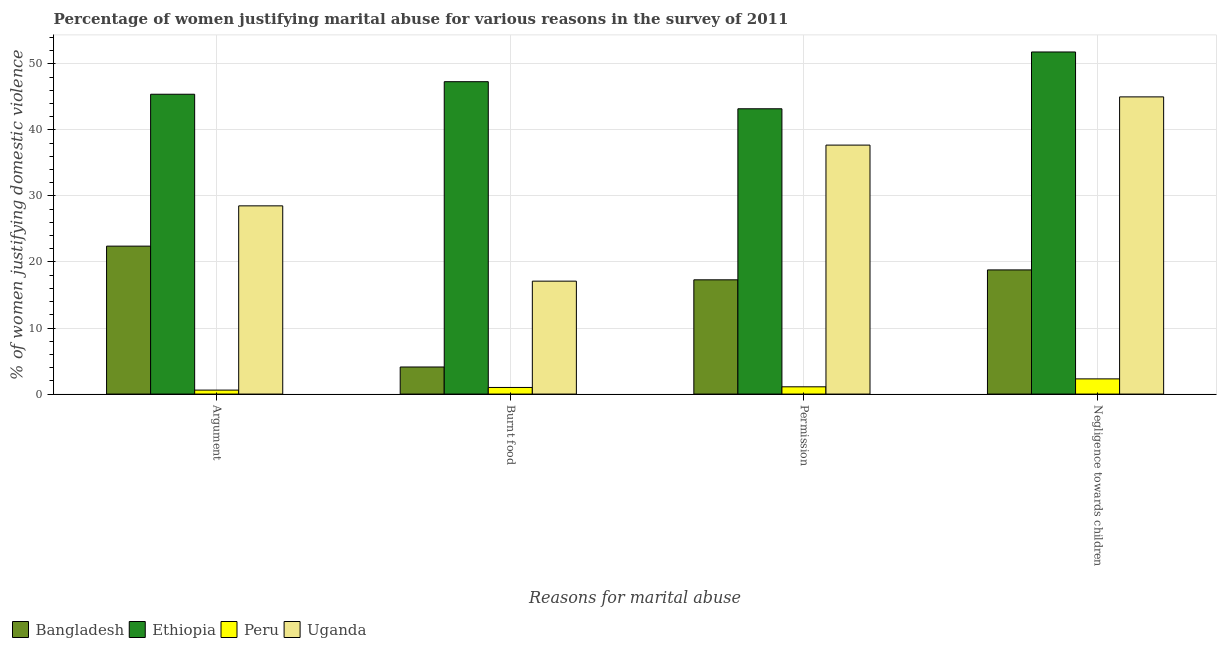How many different coloured bars are there?
Keep it short and to the point. 4. How many groups of bars are there?
Keep it short and to the point. 4. Are the number of bars on each tick of the X-axis equal?
Offer a very short reply. Yes. How many bars are there on the 3rd tick from the right?
Your answer should be very brief. 4. What is the label of the 4th group of bars from the left?
Your answer should be very brief. Negligence towards children. What is the percentage of women justifying abuse for showing negligence towards children in Uganda?
Offer a very short reply. 45. Across all countries, what is the maximum percentage of women justifying abuse for going without permission?
Provide a succinct answer. 43.2. In which country was the percentage of women justifying abuse for going without permission maximum?
Your response must be concise. Ethiopia. In which country was the percentage of women justifying abuse for burning food minimum?
Provide a succinct answer. Peru. What is the total percentage of women justifying abuse for going without permission in the graph?
Ensure brevity in your answer.  99.3. What is the difference between the percentage of women justifying abuse for showing negligence towards children in Peru and that in Uganda?
Give a very brief answer. -42.7. What is the difference between the percentage of women justifying abuse in the case of an argument in Ethiopia and the percentage of women justifying abuse for going without permission in Uganda?
Make the answer very short. 7.7. What is the average percentage of women justifying abuse for burning food per country?
Offer a very short reply. 17.38. What is the difference between the percentage of women justifying abuse in the case of an argument and percentage of women justifying abuse for showing negligence towards children in Uganda?
Offer a very short reply. -16.5. What is the ratio of the percentage of women justifying abuse in the case of an argument in Peru to that in Ethiopia?
Ensure brevity in your answer.  0.01. Is the percentage of women justifying abuse for burning food in Peru less than that in Ethiopia?
Keep it short and to the point. Yes. What is the difference between the highest and the lowest percentage of women justifying abuse for showing negligence towards children?
Offer a terse response. 49.5. In how many countries, is the percentage of women justifying abuse in the case of an argument greater than the average percentage of women justifying abuse in the case of an argument taken over all countries?
Keep it short and to the point. 2. What does the 4th bar from the left in Burnt food represents?
Ensure brevity in your answer.  Uganda. What does the 2nd bar from the right in Burnt food represents?
Offer a very short reply. Peru. Is it the case that in every country, the sum of the percentage of women justifying abuse in the case of an argument and percentage of women justifying abuse for burning food is greater than the percentage of women justifying abuse for going without permission?
Your response must be concise. Yes. How many bars are there?
Make the answer very short. 16. How many countries are there in the graph?
Your answer should be compact. 4. Does the graph contain any zero values?
Give a very brief answer. No. How are the legend labels stacked?
Keep it short and to the point. Horizontal. What is the title of the graph?
Make the answer very short. Percentage of women justifying marital abuse for various reasons in the survey of 2011. Does "Kuwait" appear as one of the legend labels in the graph?
Your answer should be very brief. No. What is the label or title of the X-axis?
Provide a short and direct response. Reasons for marital abuse. What is the label or title of the Y-axis?
Your response must be concise. % of women justifying domestic violence. What is the % of women justifying domestic violence in Bangladesh in Argument?
Your answer should be very brief. 22.4. What is the % of women justifying domestic violence of Ethiopia in Argument?
Your answer should be very brief. 45.4. What is the % of women justifying domestic violence of Ethiopia in Burnt food?
Make the answer very short. 47.3. What is the % of women justifying domestic violence of Peru in Burnt food?
Your answer should be compact. 1. What is the % of women justifying domestic violence of Uganda in Burnt food?
Ensure brevity in your answer.  17.1. What is the % of women justifying domestic violence of Bangladesh in Permission?
Make the answer very short. 17.3. What is the % of women justifying domestic violence of Ethiopia in Permission?
Your answer should be very brief. 43.2. What is the % of women justifying domestic violence of Peru in Permission?
Give a very brief answer. 1.1. What is the % of women justifying domestic violence of Uganda in Permission?
Give a very brief answer. 37.7. What is the % of women justifying domestic violence of Ethiopia in Negligence towards children?
Your answer should be compact. 51.8. What is the % of women justifying domestic violence of Peru in Negligence towards children?
Provide a succinct answer. 2.3. Across all Reasons for marital abuse, what is the maximum % of women justifying domestic violence in Bangladesh?
Keep it short and to the point. 22.4. Across all Reasons for marital abuse, what is the maximum % of women justifying domestic violence of Ethiopia?
Make the answer very short. 51.8. Across all Reasons for marital abuse, what is the maximum % of women justifying domestic violence in Peru?
Your answer should be very brief. 2.3. Across all Reasons for marital abuse, what is the maximum % of women justifying domestic violence of Uganda?
Offer a very short reply. 45. Across all Reasons for marital abuse, what is the minimum % of women justifying domestic violence in Bangladesh?
Your answer should be very brief. 4.1. Across all Reasons for marital abuse, what is the minimum % of women justifying domestic violence of Ethiopia?
Ensure brevity in your answer.  43.2. Across all Reasons for marital abuse, what is the minimum % of women justifying domestic violence in Uganda?
Ensure brevity in your answer.  17.1. What is the total % of women justifying domestic violence of Bangladesh in the graph?
Keep it short and to the point. 62.6. What is the total % of women justifying domestic violence of Ethiopia in the graph?
Offer a terse response. 187.7. What is the total % of women justifying domestic violence of Peru in the graph?
Your response must be concise. 5. What is the total % of women justifying domestic violence in Uganda in the graph?
Your answer should be compact. 128.3. What is the difference between the % of women justifying domestic violence of Bangladesh in Argument and that in Burnt food?
Make the answer very short. 18.3. What is the difference between the % of women justifying domestic violence of Ethiopia in Argument and that in Burnt food?
Your answer should be very brief. -1.9. What is the difference between the % of women justifying domestic violence of Peru in Argument and that in Permission?
Provide a short and direct response. -0.5. What is the difference between the % of women justifying domestic violence of Uganda in Argument and that in Permission?
Keep it short and to the point. -9.2. What is the difference between the % of women justifying domestic violence of Bangladesh in Argument and that in Negligence towards children?
Your response must be concise. 3.6. What is the difference between the % of women justifying domestic violence in Uganda in Argument and that in Negligence towards children?
Your answer should be compact. -16.5. What is the difference between the % of women justifying domestic violence of Bangladesh in Burnt food and that in Permission?
Provide a short and direct response. -13.2. What is the difference between the % of women justifying domestic violence of Ethiopia in Burnt food and that in Permission?
Offer a terse response. 4.1. What is the difference between the % of women justifying domestic violence in Uganda in Burnt food and that in Permission?
Your answer should be compact. -20.6. What is the difference between the % of women justifying domestic violence in Bangladesh in Burnt food and that in Negligence towards children?
Provide a short and direct response. -14.7. What is the difference between the % of women justifying domestic violence of Ethiopia in Burnt food and that in Negligence towards children?
Ensure brevity in your answer.  -4.5. What is the difference between the % of women justifying domestic violence in Peru in Burnt food and that in Negligence towards children?
Ensure brevity in your answer.  -1.3. What is the difference between the % of women justifying domestic violence of Uganda in Burnt food and that in Negligence towards children?
Keep it short and to the point. -27.9. What is the difference between the % of women justifying domestic violence in Bangladesh in Permission and that in Negligence towards children?
Make the answer very short. -1.5. What is the difference between the % of women justifying domestic violence of Ethiopia in Permission and that in Negligence towards children?
Your response must be concise. -8.6. What is the difference between the % of women justifying domestic violence of Peru in Permission and that in Negligence towards children?
Give a very brief answer. -1.2. What is the difference between the % of women justifying domestic violence of Uganda in Permission and that in Negligence towards children?
Your answer should be compact. -7.3. What is the difference between the % of women justifying domestic violence of Bangladesh in Argument and the % of women justifying domestic violence of Ethiopia in Burnt food?
Your answer should be very brief. -24.9. What is the difference between the % of women justifying domestic violence of Bangladesh in Argument and the % of women justifying domestic violence of Peru in Burnt food?
Your answer should be compact. 21.4. What is the difference between the % of women justifying domestic violence in Bangladesh in Argument and the % of women justifying domestic violence in Uganda in Burnt food?
Your answer should be compact. 5.3. What is the difference between the % of women justifying domestic violence of Ethiopia in Argument and the % of women justifying domestic violence of Peru in Burnt food?
Provide a short and direct response. 44.4. What is the difference between the % of women justifying domestic violence in Ethiopia in Argument and the % of women justifying domestic violence in Uganda in Burnt food?
Make the answer very short. 28.3. What is the difference between the % of women justifying domestic violence of Peru in Argument and the % of women justifying domestic violence of Uganda in Burnt food?
Provide a short and direct response. -16.5. What is the difference between the % of women justifying domestic violence in Bangladesh in Argument and the % of women justifying domestic violence in Ethiopia in Permission?
Keep it short and to the point. -20.8. What is the difference between the % of women justifying domestic violence in Bangladesh in Argument and the % of women justifying domestic violence in Peru in Permission?
Your answer should be compact. 21.3. What is the difference between the % of women justifying domestic violence in Bangladesh in Argument and the % of women justifying domestic violence in Uganda in Permission?
Offer a very short reply. -15.3. What is the difference between the % of women justifying domestic violence of Ethiopia in Argument and the % of women justifying domestic violence of Peru in Permission?
Your response must be concise. 44.3. What is the difference between the % of women justifying domestic violence of Peru in Argument and the % of women justifying domestic violence of Uganda in Permission?
Your response must be concise. -37.1. What is the difference between the % of women justifying domestic violence of Bangladesh in Argument and the % of women justifying domestic violence of Ethiopia in Negligence towards children?
Offer a very short reply. -29.4. What is the difference between the % of women justifying domestic violence in Bangladesh in Argument and the % of women justifying domestic violence in Peru in Negligence towards children?
Ensure brevity in your answer.  20.1. What is the difference between the % of women justifying domestic violence of Bangladesh in Argument and the % of women justifying domestic violence of Uganda in Negligence towards children?
Your answer should be very brief. -22.6. What is the difference between the % of women justifying domestic violence of Ethiopia in Argument and the % of women justifying domestic violence of Peru in Negligence towards children?
Offer a very short reply. 43.1. What is the difference between the % of women justifying domestic violence in Peru in Argument and the % of women justifying domestic violence in Uganda in Negligence towards children?
Provide a short and direct response. -44.4. What is the difference between the % of women justifying domestic violence of Bangladesh in Burnt food and the % of women justifying domestic violence of Ethiopia in Permission?
Provide a succinct answer. -39.1. What is the difference between the % of women justifying domestic violence of Bangladesh in Burnt food and the % of women justifying domestic violence of Peru in Permission?
Make the answer very short. 3. What is the difference between the % of women justifying domestic violence of Bangladesh in Burnt food and the % of women justifying domestic violence of Uganda in Permission?
Keep it short and to the point. -33.6. What is the difference between the % of women justifying domestic violence in Ethiopia in Burnt food and the % of women justifying domestic violence in Peru in Permission?
Provide a succinct answer. 46.2. What is the difference between the % of women justifying domestic violence in Ethiopia in Burnt food and the % of women justifying domestic violence in Uganda in Permission?
Ensure brevity in your answer.  9.6. What is the difference between the % of women justifying domestic violence in Peru in Burnt food and the % of women justifying domestic violence in Uganda in Permission?
Your answer should be very brief. -36.7. What is the difference between the % of women justifying domestic violence of Bangladesh in Burnt food and the % of women justifying domestic violence of Ethiopia in Negligence towards children?
Give a very brief answer. -47.7. What is the difference between the % of women justifying domestic violence of Bangladesh in Burnt food and the % of women justifying domestic violence of Uganda in Negligence towards children?
Your response must be concise. -40.9. What is the difference between the % of women justifying domestic violence of Ethiopia in Burnt food and the % of women justifying domestic violence of Peru in Negligence towards children?
Your answer should be very brief. 45. What is the difference between the % of women justifying domestic violence in Peru in Burnt food and the % of women justifying domestic violence in Uganda in Negligence towards children?
Give a very brief answer. -44. What is the difference between the % of women justifying domestic violence of Bangladesh in Permission and the % of women justifying domestic violence of Ethiopia in Negligence towards children?
Keep it short and to the point. -34.5. What is the difference between the % of women justifying domestic violence in Bangladesh in Permission and the % of women justifying domestic violence in Peru in Negligence towards children?
Give a very brief answer. 15. What is the difference between the % of women justifying domestic violence in Bangladesh in Permission and the % of women justifying domestic violence in Uganda in Negligence towards children?
Make the answer very short. -27.7. What is the difference between the % of women justifying domestic violence in Ethiopia in Permission and the % of women justifying domestic violence in Peru in Negligence towards children?
Your answer should be compact. 40.9. What is the difference between the % of women justifying domestic violence of Peru in Permission and the % of women justifying domestic violence of Uganda in Negligence towards children?
Your response must be concise. -43.9. What is the average % of women justifying domestic violence of Bangladesh per Reasons for marital abuse?
Offer a very short reply. 15.65. What is the average % of women justifying domestic violence in Ethiopia per Reasons for marital abuse?
Provide a short and direct response. 46.92. What is the average % of women justifying domestic violence in Peru per Reasons for marital abuse?
Provide a short and direct response. 1.25. What is the average % of women justifying domestic violence of Uganda per Reasons for marital abuse?
Offer a terse response. 32.08. What is the difference between the % of women justifying domestic violence of Bangladesh and % of women justifying domestic violence of Peru in Argument?
Keep it short and to the point. 21.8. What is the difference between the % of women justifying domestic violence in Bangladesh and % of women justifying domestic violence in Uganda in Argument?
Make the answer very short. -6.1. What is the difference between the % of women justifying domestic violence in Ethiopia and % of women justifying domestic violence in Peru in Argument?
Offer a very short reply. 44.8. What is the difference between the % of women justifying domestic violence of Peru and % of women justifying domestic violence of Uganda in Argument?
Your answer should be compact. -27.9. What is the difference between the % of women justifying domestic violence of Bangladesh and % of women justifying domestic violence of Ethiopia in Burnt food?
Provide a succinct answer. -43.2. What is the difference between the % of women justifying domestic violence of Bangladesh and % of women justifying domestic violence of Peru in Burnt food?
Ensure brevity in your answer.  3.1. What is the difference between the % of women justifying domestic violence of Ethiopia and % of women justifying domestic violence of Peru in Burnt food?
Keep it short and to the point. 46.3. What is the difference between the % of women justifying domestic violence in Ethiopia and % of women justifying domestic violence in Uganda in Burnt food?
Provide a short and direct response. 30.2. What is the difference between the % of women justifying domestic violence in Peru and % of women justifying domestic violence in Uganda in Burnt food?
Provide a succinct answer. -16.1. What is the difference between the % of women justifying domestic violence in Bangladesh and % of women justifying domestic violence in Ethiopia in Permission?
Make the answer very short. -25.9. What is the difference between the % of women justifying domestic violence in Bangladesh and % of women justifying domestic violence in Uganda in Permission?
Your response must be concise. -20.4. What is the difference between the % of women justifying domestic violence of Ethiopia and % of women justifying domestic violence of Peru in Permission?
Ensure brevity in your answer.  42.1. What is the difference between the % of women justifying domestic violence of Ethiopia and % of women justifying domestic violence of Uganda in Permission?
Provide a short and direct response. 5.5. What is the difference between the % of women justifying domestic violence of Peru and % of women justifying domestic violence of Uganda in Permission?
Ensure brevity in your answer.  -36.6. What is the difference between the % of women justifying domestic violence of Bangladesh and % of women justifying domestic violence of Ethiopia in Negligence towards children?
Provide a succinct answer. -33. What is the difference between the % of women justifying domestic violence of Bangladesh and % of women justifying domestic violence of Uganda in Negligence towards children?
Your answer should be very brief. -26.2. What is the difference between the % of women justifying domestic violence in Ethiopia and % of women justifying domestic violence in Peru in Negligence towards children?
Make the answer very short. 49.5. What is the difference between the % of women justifying domestic violence in Peru and % of women justifying domestic violence in Uganda in Negligence towards children?
Your response must be concise. -42.7. What is the ratio of the % of women justifying domestic violence in Bangladesh in Argument to that in Burnt food?
Your response must be concise. 5.46. What is the ratio of the % of women justifying domestic violence in Ethiopia in Argument to that in Burnt food?
Ensure brevity in your answer.  0.96. What is the ratio of the % of women justifying domestic violence in Bangladesh in Argument to that in Permission?
Provide a succinct answer. 1.29. What is the ratio of the % of women justifying domestic violence of Ethiopia in Argument to that in Permission?
Offer a terse response. 1.05. What is the ratio of the % of women justifying domestic violence in Peru in Argument to that in Permission?
Your answer should be very brief. 0.55. What is the ratio of the % of women justifying domestic violence of Uganda in Argument to that in Permission?
Make the answer very short. 0.76. What is the ratio of the % of women justifying domestic violence in Bangladesh in Argument to that in Negligence towards children?
Make the answer very short. 1.19. What is the ratio of the % of women justifying domestic violence of Ethiopia in Argument to that in Negligence towards children?
Give a very brief answer. 0.88. What is the ratio of the % of women justifying domestic violence in Peru in Argument to that in Negligence towards children?
Your response must be concise. 0.26. What is the ratio of the % of women justifying domestic violence of Uganda in Argument to that in Negligence towards children?
Your response must be concise. 0.63. What is the ratio of the % of women justifying domestic violence of Bangladesh in Burnt food to that in Permission?
Your response must be concise. 0.24. What is the ratio of the % of women justifying domestic violence of Ethiopia in Burnt food to that in Permission?
Your answer should be very brief. 1.09. What is the ratio of the % of women justifying domestic violence of Peru in Burnt food to that in Permission?
Offer a terse response. 0.91. What is the ratio of the % of women justifying domestic violence of Uganda in Burnt food to that in Permission?
Keep it short and to the point. 0.45. What is the ratio of the % of women justifying domestic violence of Bangladesh in Burnt food to that in Negligence towards children?
Provide a short and direct response. 0.22. What is the ratio of the % of women justifying domestic violence of Ethiopia in Burnt food to that in Negligence towards children?
Your response must be concise. 0.91. What is the ratio of the % of women justifying domestic violence in Peru in Burnt food to that in Negligence towards children?
Your response must be concise. 0.43. What is the ratio of the % of women justifying domestic violence in Uganda in Burnt food to that in Negligence towards children?
Provide a succinct answer. 0.38. What is the ratio of the % of women justifying domestic violence in Bangladesh in Permission to that in Negligence towards children?
Offer a terse response. 0.92. What is the ratio of the % of women justifying domestic violence of Ethiopia in Permission to that in Negligence towards children?
Your answer should be compact. 0.83. What is the ratio of the % of women justifying domestic violence of Peru in Permission to that in Negligence towards children?
Offer a terse response. 0.48. What is the ratio of the % of women justifying domestic violence of Uganda in Permission to that in Negligence towards children?
Offer a very short reply. 0.84. What is the difference between the highest and the second highest % of women justifying domestic violence of Ethiopia?
Offer a terse response. 4.5. What is the difference between the highest and the lowest % of women justifying domestic violence in Bangladesh?
Your response must be concise. 18.3. What is the difference between the highest and the lowest % of women justifying domestic violence in Ethiopia?
Give a very brief answer. 8.6. What is the difference between the highest and the lowest % of women justifying domestic violence in Uganda?
Ensure brevity in your answer.  27.9. 